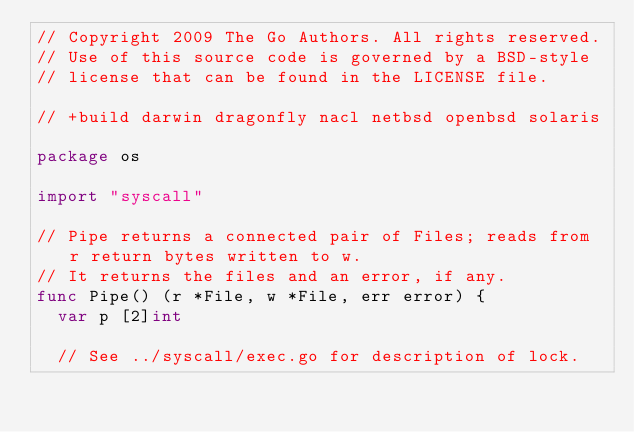Convert code to text. <code><loc_0><loc_0><loc_500><loc_500><_Go_>// Copyright 2009 The Go Authors. All rights reserved.
// Use of this source code is governed by a BSD-style
// license that can be found in the LICENSE file.

// +build darwin dragonfly nacl netbsd openbsd solaris

package os

import "syscall"

// Pipe returns a connected pair of Files; reads from r return bytes written to w.
// It returns the files and an error, if any.
func Pipe() (r *File, w *File, err error) {
	var p [2]int

	// See ../syscall/exec.go for description of lock.</code> 